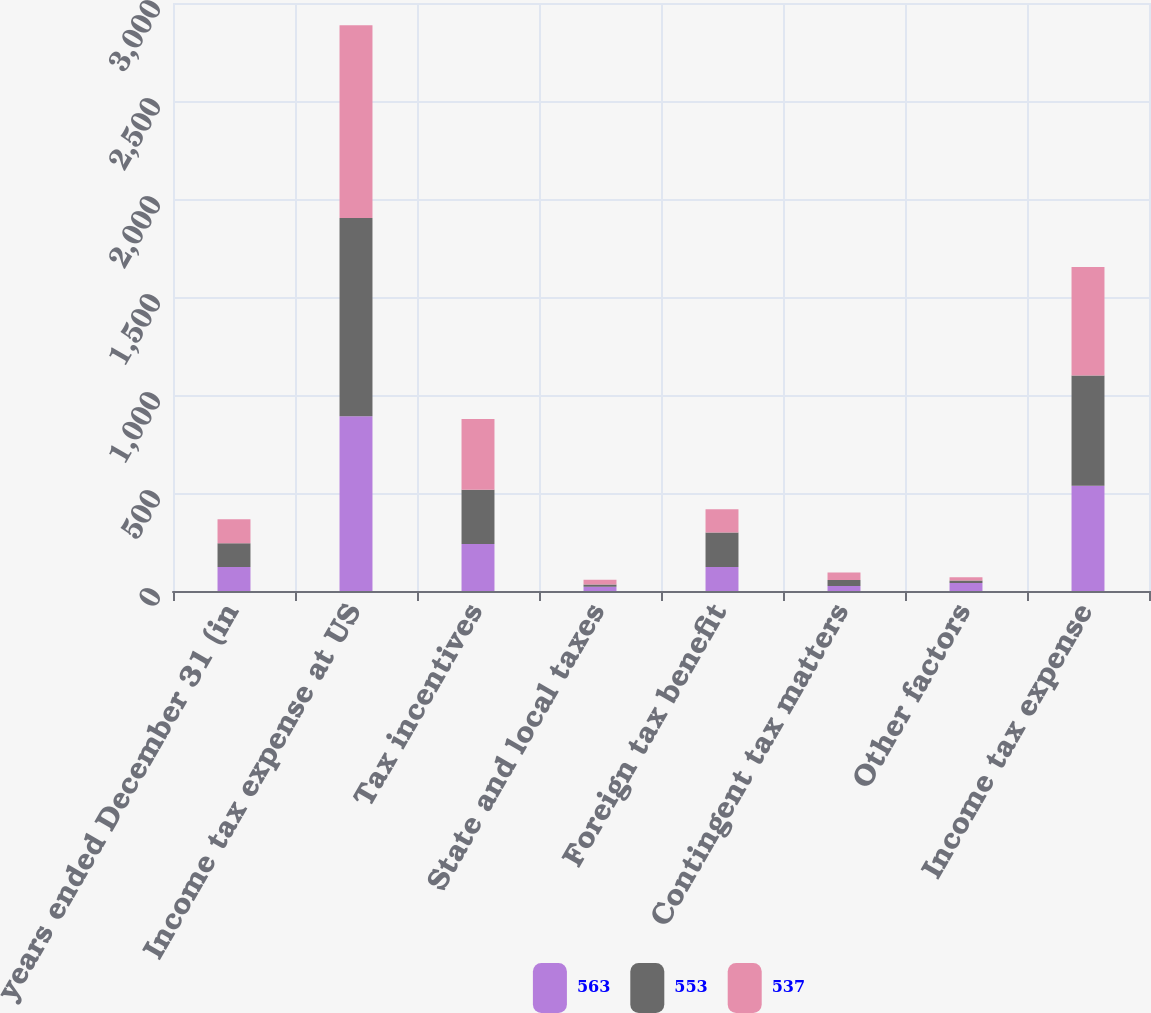Convert chart to OTSL. <chart><loc_0><loc_0><loc_500><loc_500><stacked_bar_chart><ecel><fcel>years ended December 31 (in<fcel>Income tax expense at US<fcel>Tax incentives<fcel>State and local taxes<fcel>Foreign tax benefit<fcel>Contingent tax matters<fcel>Other factors<fcel>Income tax expense<nl><fcel>563<fcel>122<fcel>892<fcel>240<fcel>22<fcel>122<fcel>26<fcel>41<fcel>537<nl><fcel>553<fcel>122<fcel>1011<fcel>277<fcel>11<fcel>177<fcel>30<fcel>13<fcel>563<nl><fcel>537<fcel>122<fcel>983<fcel>360<fcel>25<fcel>118<fcel>39<fcel>16<fcel>553<nl></chart> 